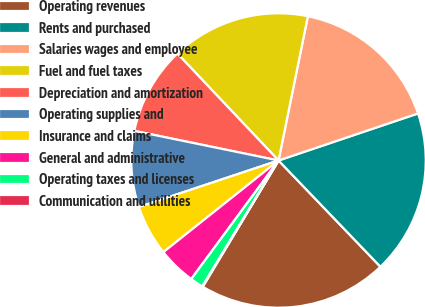<chart> <loc_0><loc_0><loc_500><loc_500><pie_chart><fcel>Operating revenues<fcel>Rents and purchased<fcel>Salaries wages and employee<fcel>Fuel and fuel taxes<fcel>Depreciation and amortization<fcel>Operating supplies and<fcel>Insurance and claims<fcel>General and administrative<fcel>Operating taxes and licenses<fcel>Communication and utilities<nl><fcel>20.77%<fcel>18.01%<fcel>16.63%<fcel>15.25%<fcel>9.72%<fcel>8.34%<fcel>5.58%<fcel>4.2%<fcel>1.44%<fcel>0.06%<nl></chart> 